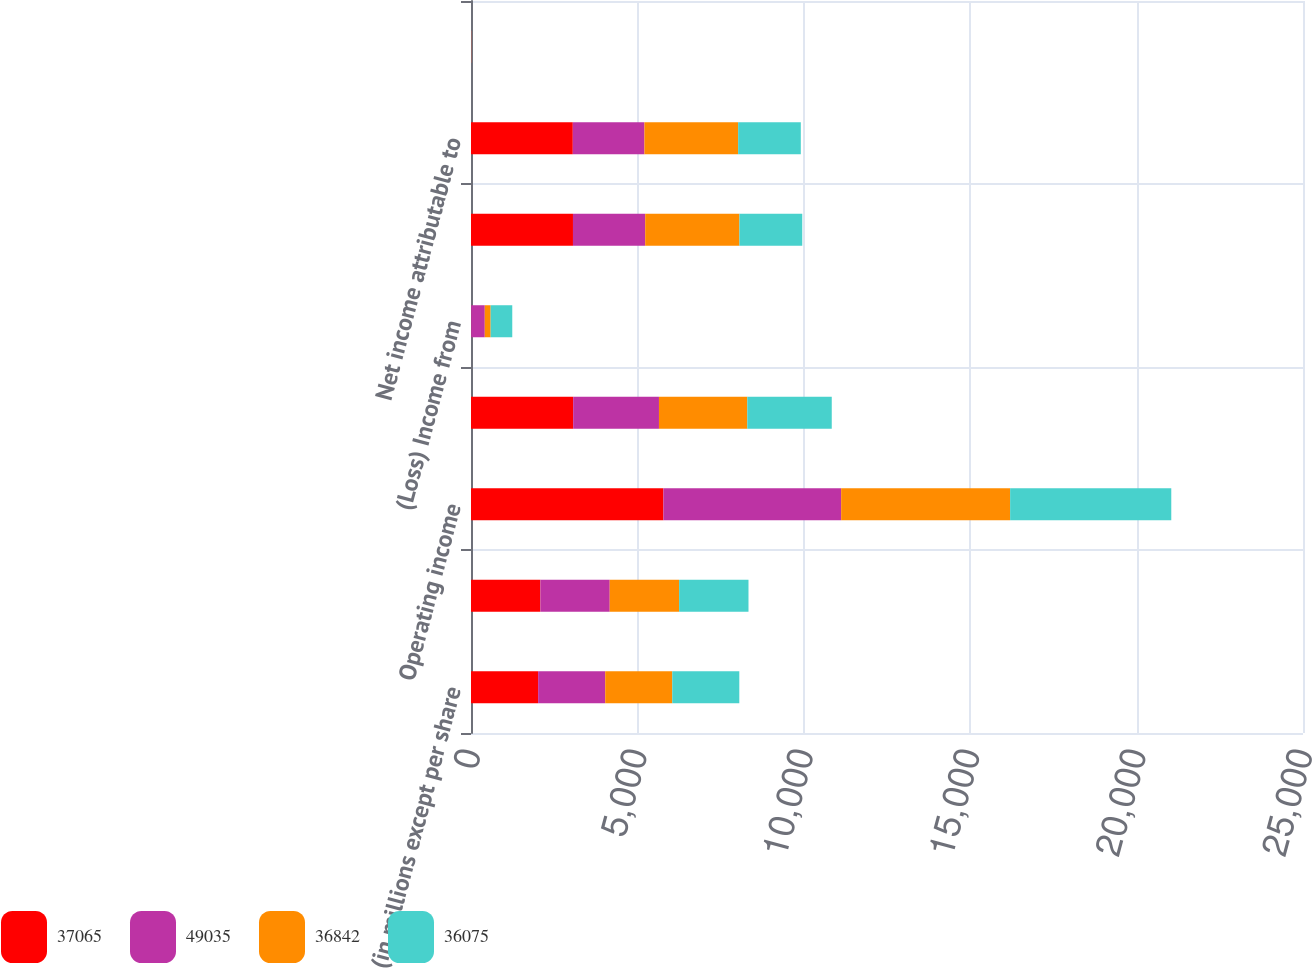Convert chart to OTSL. <chart><loc_0><loc_0><loc_500><loc_500><stacked_bar_chart><ecel><fcel>(in millions except per share<fcel>Total operating revenues<fcel>Operating income<fcel>Income from continuing<fcel>(Loss) Income from<fcel>Net income<fcel>Net income attributable to<fcel>Basic<nl><fcel>37065<fcel>2017<fcel>2084.5<fcel>5781<fcel>3070<fcel>6<fcel>3064<fcel>3059<fcel>4.37<nl><fcel>49035<fcel>2016<fcel>2084.5<fcel>5341<fcel>2578<fcel>408<fcel>2170<fcel>2152<fcel>3.71<nl><fcel>36842<fcel>2015<fcel>2084.5<fcel>5078<fcel>2654<fcel>177<fcel>2831<fcel>2816<fcel>3.8<nl><fcel>36075<fcel>2014<fcel>2084.5<fcel>4842<fcel>2538<fcel>649<fcel>1889<fcel>1883<fcel>3.58<nl></chart> 